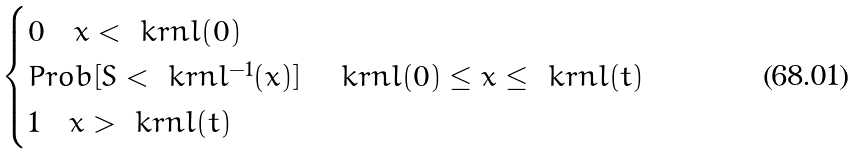<formula> <loc_0><loc_0><loc_500><loc_500>\begin{cases} 0 \quad x < \ k r n l ( 0 ) \\ P r o b [ S < \ k r n l ^ { - 1 } ( x ) ] \quad \ k r n l ( 0 ) \leq x \leq \ k r n l ( t ) \\ 1 \quad x > \ k r n l ( t ) \end{cases}</formula> 